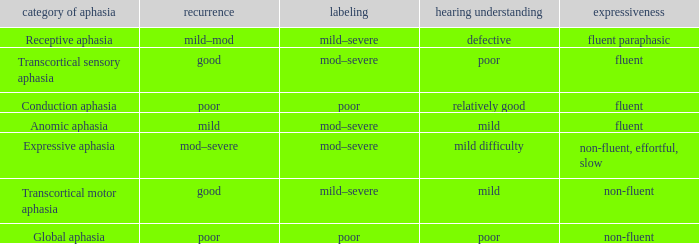Name the comprehension for non-fluent, effortful, slow Mild difficulty. 